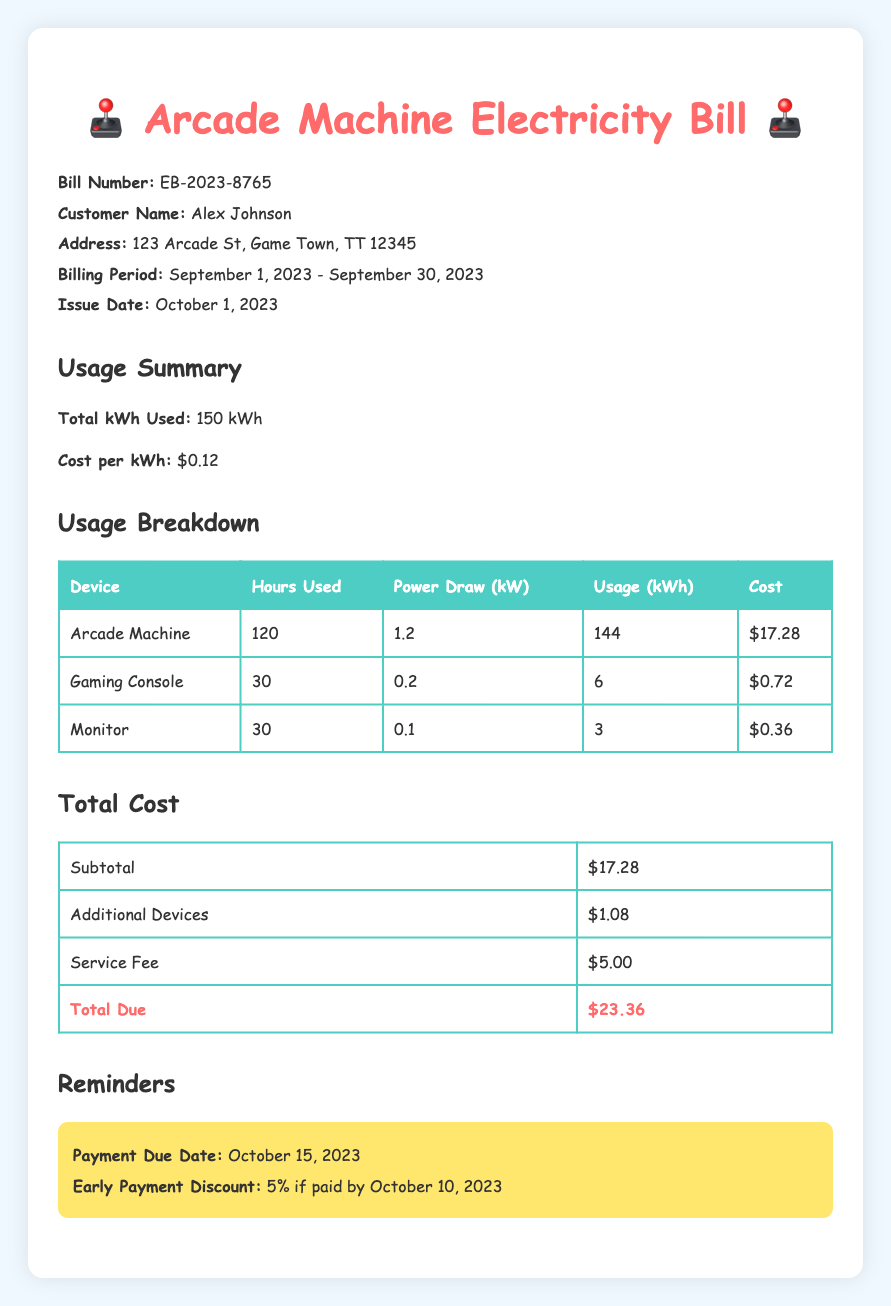What is the billing period? The billing period is the time frame for which the electricity usage is calculated, which is September 1, 2023 - September 30, 2023.
Answer: September 1, 2023 - September 30, 2023 How many kilowatt-hours were used in total? The total kWh used is a specific metric listed in the Usage Summary section, which shows the total electricity consumption.
Answer: 150 kWh What is the cost per kilowatt-hour? The cost per kWh is detailed in the Usage Summary, indicating how much one unit of electricity costs.
Answer: $0.12 What is the total due amount? The total due is found in the Total Cost section and represents the overall amount to be paid for the electricity usage.
Answer: $23.36 How much did the arcade machine cost to operate? The cost for the arcade machine is specifically mentioned in the Breakdown table as the cost for using that device.
Answer: $17.28 What is the early payment discount percentage? The early payment discount is mentioned in the Reminders section providing information about financial incentives for paying early.
Answer: 5% How many hours did the gaming console get used? The hours used for the gaming console can be found in the Usage Breakdown table, detailing the usage for each device.
Answer: 30 What is the service fee listed? The service fee is part of the Total Cost breakdown that lists any additional fees charged to the customer.
Answer: $5.00 What is the issue date of the bill? The issue date is the date when the bill was generated, which is an important date to note for payment purposes.
Answer: October 1, 2023 